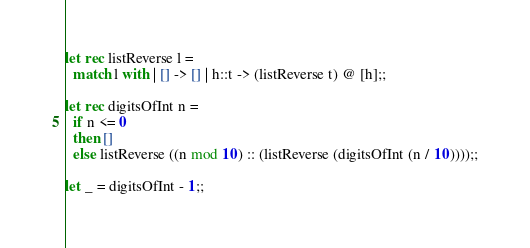Convert code to text. <code><loc_0><loc_0><loc_500><loc_500><_OCaml_>
let rec listReverse l =
  match l with | [] -> [] | h::t -> (listReverse t) @ [h];;

let rec digitsOfInt n =
  if n <= 0
  then []
  else listReverse ((n mod 10) :: (listReverse (digitsOfInt (n / 10))));;

let _ = digitsOfInt - 1;;
</code> 